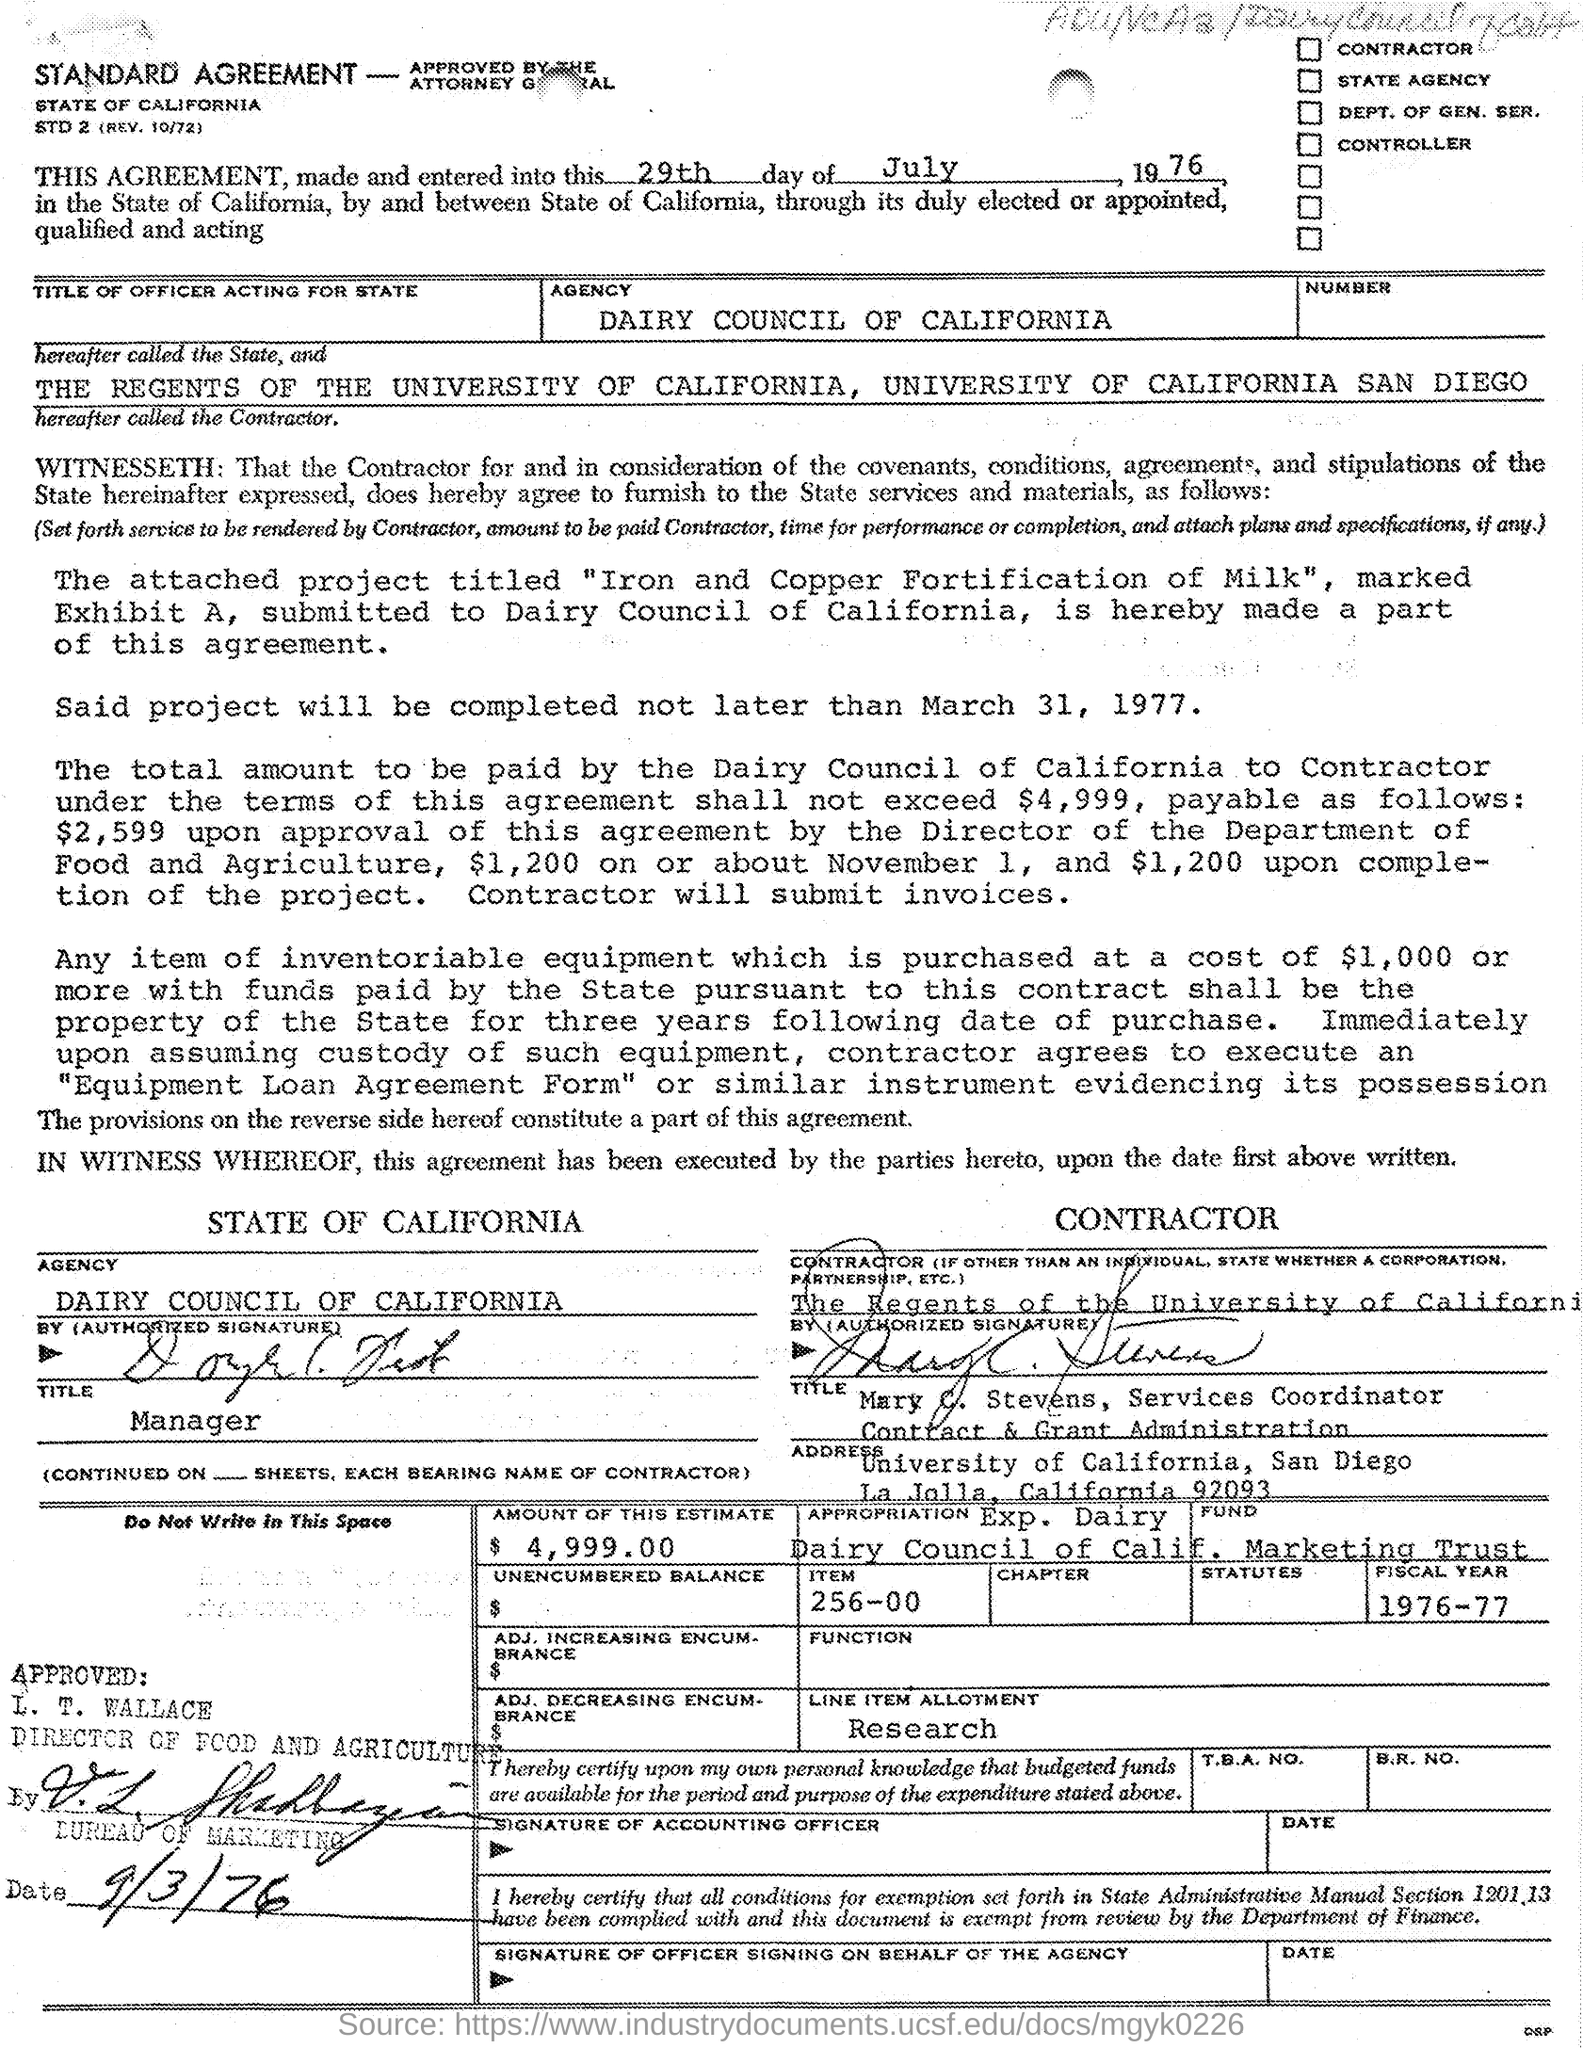When is the agreement made as per the document given?
Make the answer very short. 29th day of July, 1976. What is the approved date of this agreement?
Offer a terse response. 9/3/76. What is the Fiscal Year given in the document?
Offer a very short reply. 1976-77. 